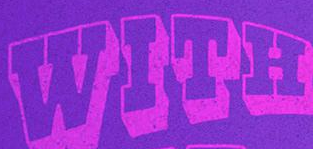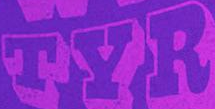What text appears in these images from left to right, separated by a semicolon? WITH; TYR 